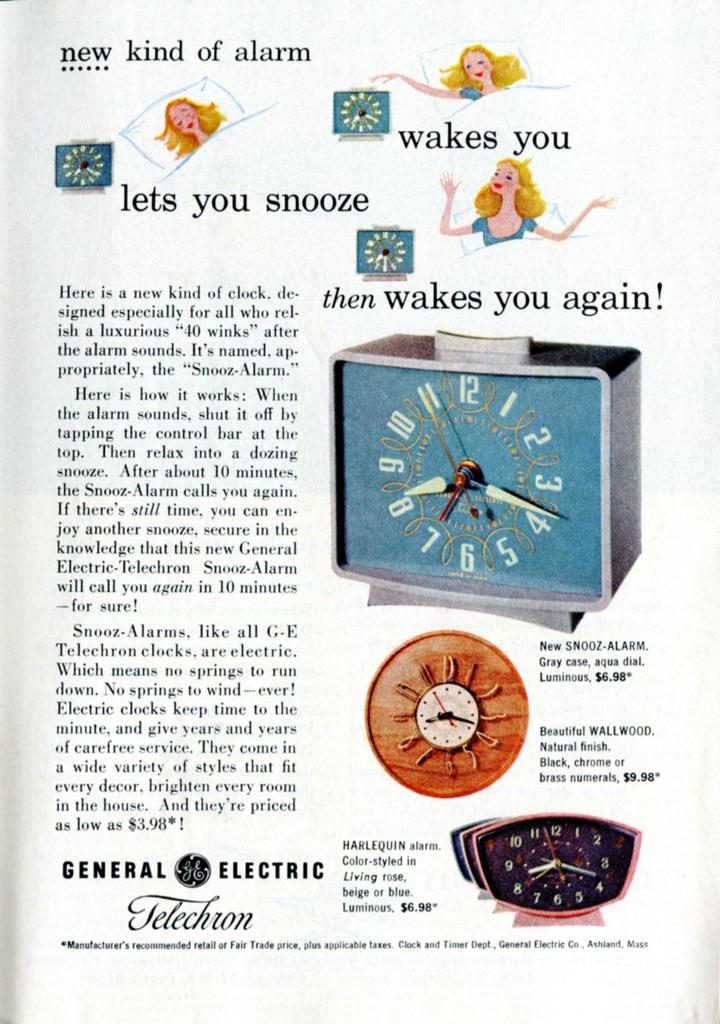What brand id this alarm clock?
Provide a succinct answer. General electric. 